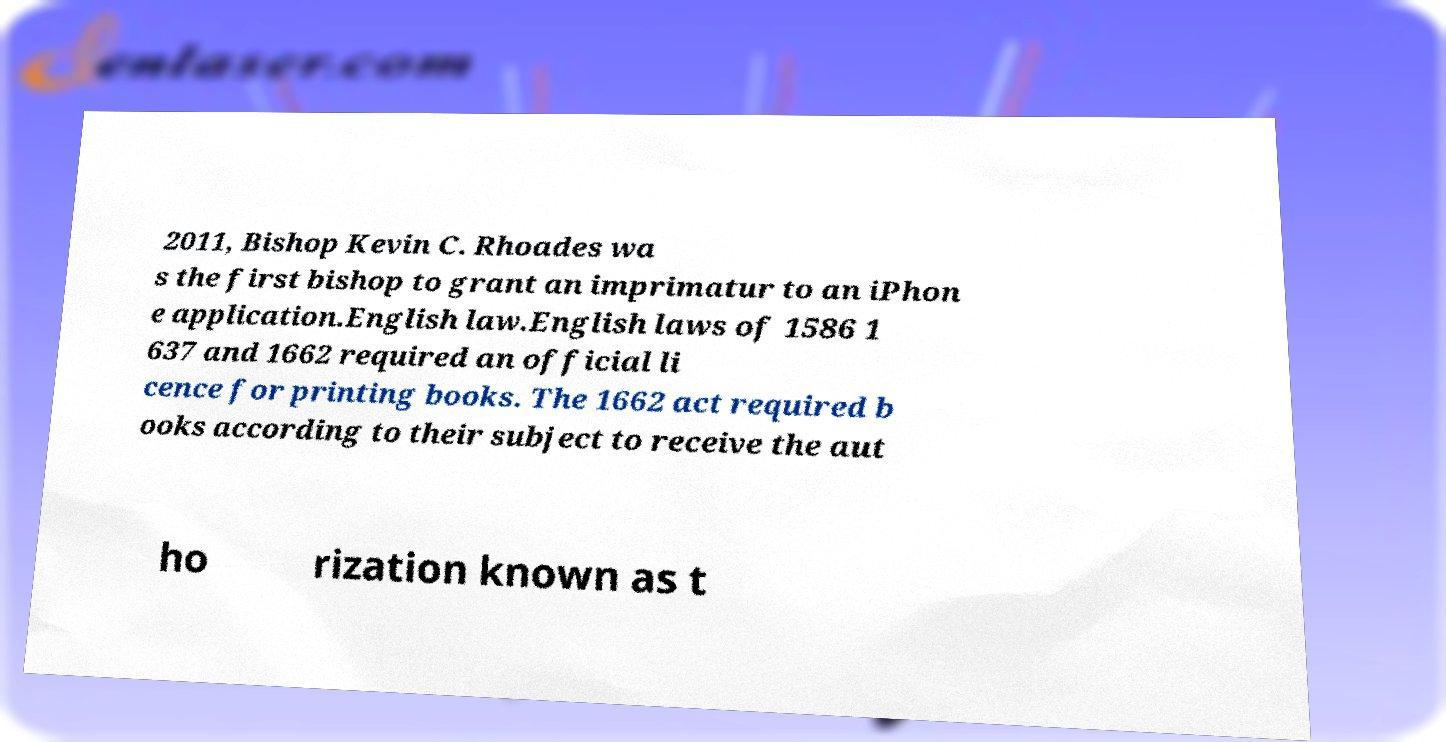Could you assist in decoding the text presented in this image and type it out clearly? 2011, Bishop Kevin C. Rhoades wa s the first bishop to grant an imprimatur to an iPhon e application.English law.English laws of 1586 1 637 and 1662 required an official li cence for printing books. The 1662 act required b ooks according to their subject to receive the aut ho rization known as t 